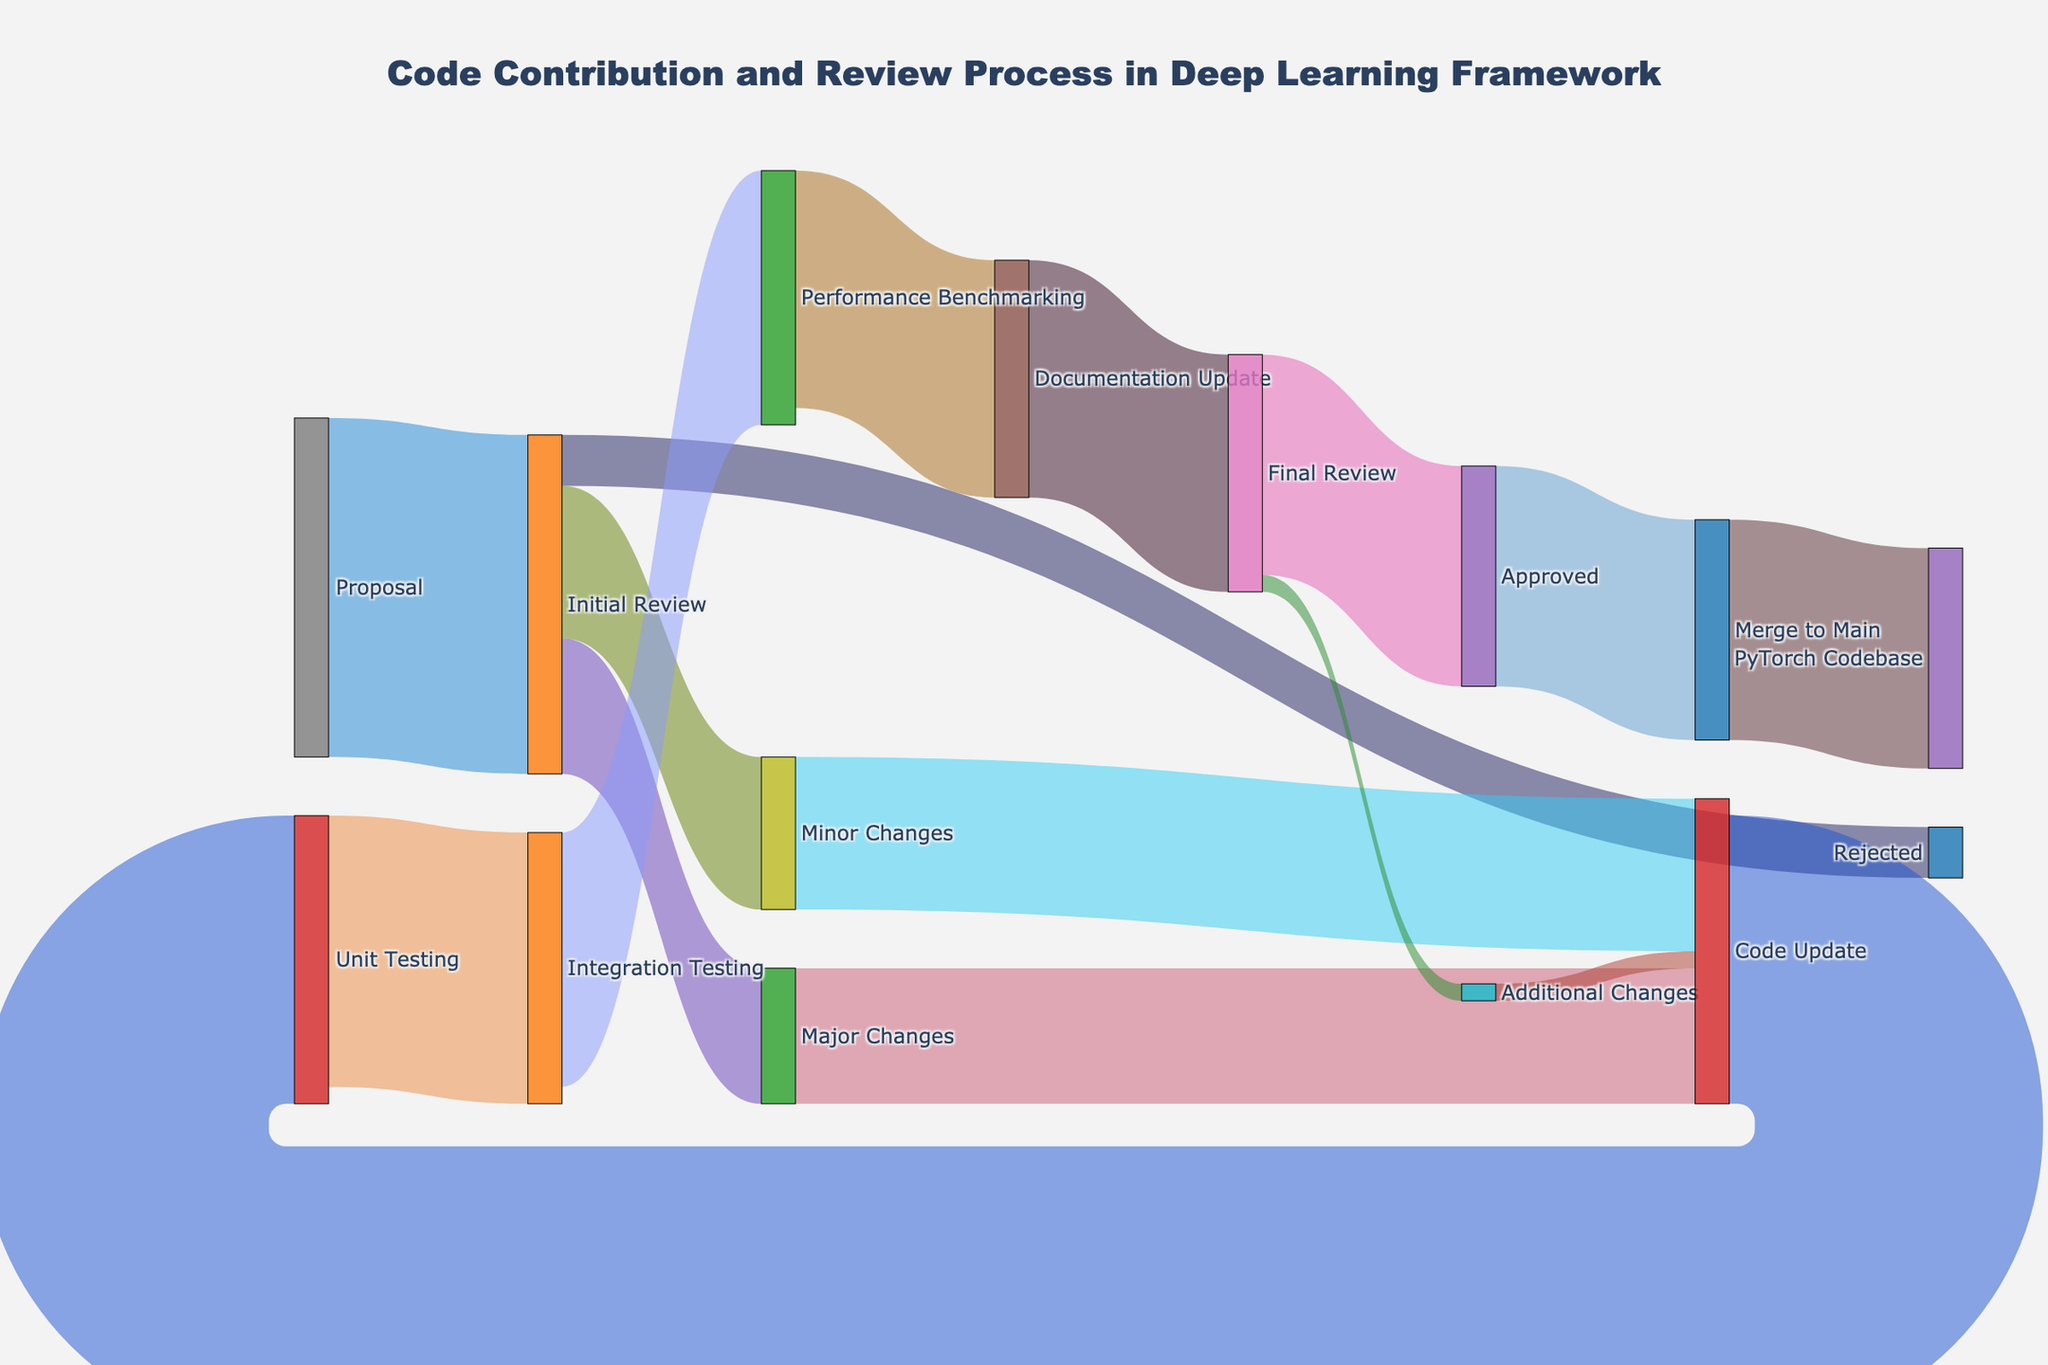How many proposals move to Final Review after Initial Review? Follow the pathway from "Initial Review" to "Final Review". First, 45 proposals go to "Minor Changes", and 40 go to "Major Changes". Next, those proposals converge at "Code Update" and move to "Unit Testing" (85). This continues through "Integration Testing" (80), "Performance Benchmarking" (75), and "Documentation Update" (70), finally leading to "Final Review" (70).
Answer: 70 What's the overall approval rate from "Proposal" to "Approved"? Total proposals are 100. Follow the flow through the entire review process to "Final Review", where 65 are "Approved". Hence, the approval rate is (65/100)*100.
Answer: 65% Which stage has the highest number of transitions, excluding the initial proposal stage? The stages with their transitions are: Initial Review (4), Code Update (1), Unit Testing (1), Integration Testing (1), Performance Benchmarking (1), Documentation Update (1), Final Review (2), Additional Changes (1), and Merge to Main (1). "Initial Review" has the highest number of transitions.
Answer: Initial Review What proportion of the initial proposals require "Minor Changes"? Out of 100 proposals, 45 move to "Minor Changes". Calculate the proportion by (45/100)*100.
Answer: 45% How many proposals undergo "Additional Changes" after Final Review? In "Final Review", 5 proposals need "Additional Changes". This is directly visualized from the node link.
Answer: 5 Compare the number of approved proposals with those that are merged to the PyTorch Codebase. What do you observe? 65 proposals are "Approved", and all 65 are "Merged to Main" and forwarded to "PyTorch Codebase". This shows all approved proposals are eventually merged.
Answer: Equal How many proposals get stuck before reaching the "Final Review" process and don't get approved? Initially, 100 proposals. The "Approved" ones are 65. Thus, non-approved is 100 - 65 = 35. These might have been rejected or are still in progress.
Answer: 35 Which stage in the process involves the highest reduction in proposals? Compare reductions: Initial Review to Rejected (100 to 15), Code Update to Unit Testing (85 to 80), and others. The highest reduction occurs from Initial Review (100) to Rejected (15), which is a drop of 85.
Answer: Initial Review to Rejected What's the ratio of proposals that make it to "Performance Benchmarking" after "Integration Testing"? Following from 80 to 75, the ratio here is 75/80. So, calculate this fraction.
Answer: 0.9375 